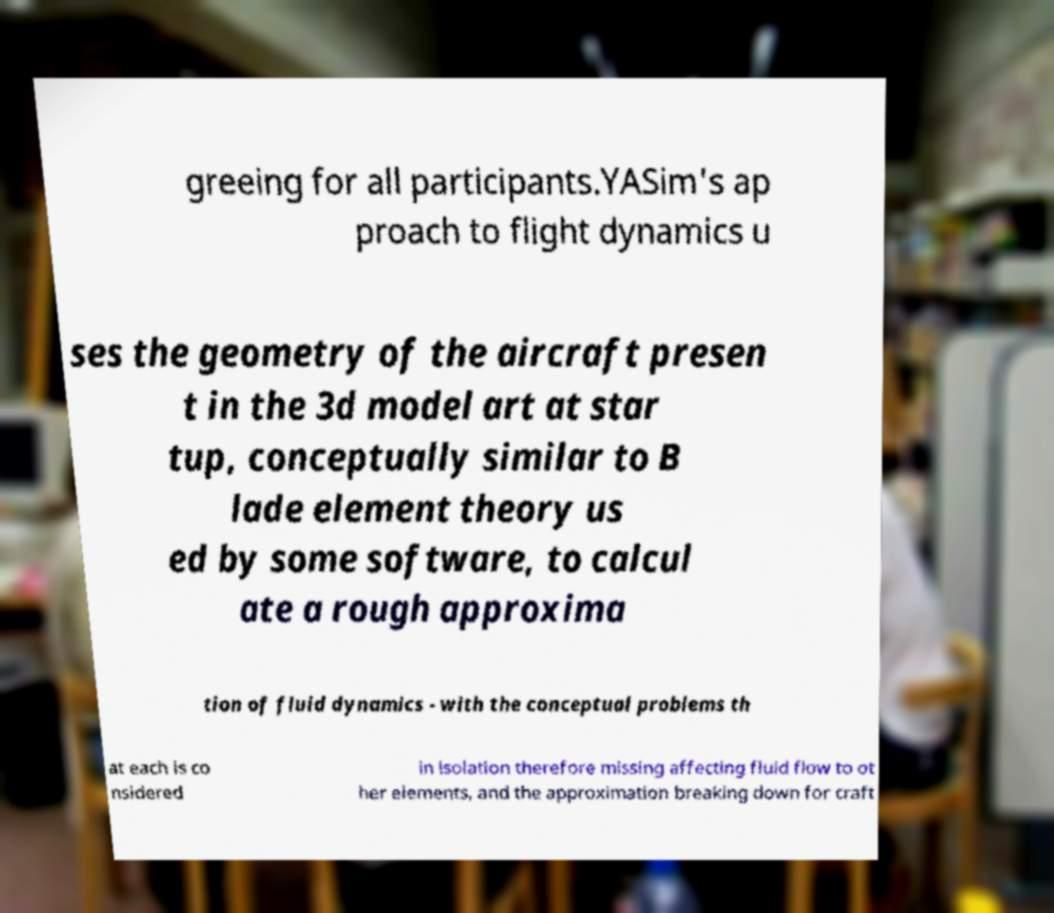There's text embedded in this image that I need extracted. Can you transcribe it verbatim? greeing for all participants.YASim's ap proach to flight dynamics u ses the geometry of the aircraft presen t in the 3d model art at star tup, conceptually similar to B lade element theory us ed by some software, to calcul ate a rough approxima tion of fluid dynamics - with the conceptual problems th at each is co nsidered in isolation therefore missing affecting fluid flow to ot her elements, and the approximation breaking down for craft 